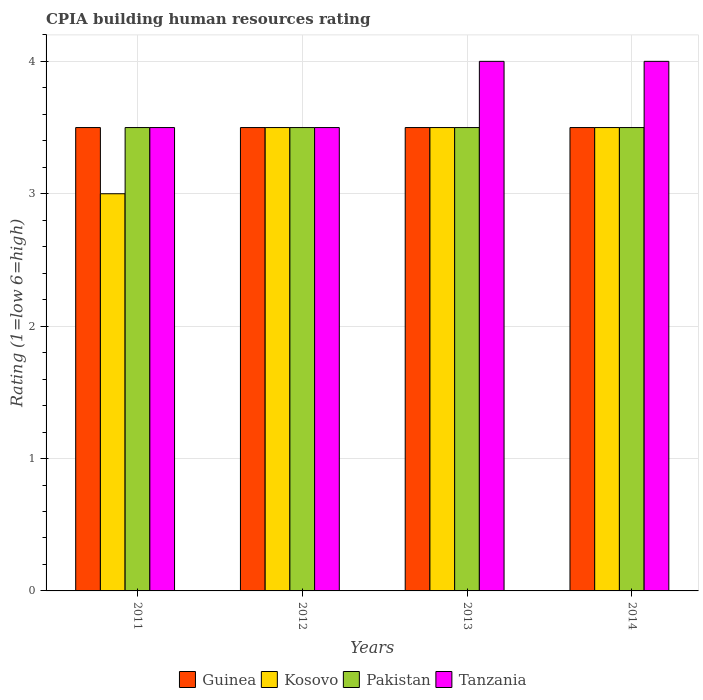Are the number of bars on each tick of the X-axis equal?
Offer a terse response. Yes. How many bars are there on the 4th tick from the left?
Offer a very short reply. 4. How many bars are there on the 2nd tick from the right?
Provide a short and direct response. 4. What is the label of the 1st group of bars from the left?
Provide a succinct answer. 2011. What is the CPIA rating in Guinea in 2014?
Provide a short and direct response. 3.5. In which year was the CPIA rating in Pakistan maximum?
Offer a very short reply. 2011. In which year was the CPIA rating in Guinea minimum?
Give a very brief answer. 2011. What is the difference between the CPIA rating in Kosovo in 2011 and that in 2012?
Give a very brief answer. -0.5. What is the average CPIA rating in Kosovo per year?
Keep it short and to the point. 3.38. What is the difference between the highest and the lowest CPIA rating in Pakistan?
Provide a succinct answer. 0. What does the 1st bar from the left in 2011 represents?
Keep it short and to the point. Guinea. How many bars are there?
Keep it short and to the point. 16. Are all the bars in the graph horizontal?
Your answer should be very brief. No. How many years are there in the graph?
Make the answer very short. 4. What is the difference between two consecutive major ticks on the Y-axis?
Offer a very short reply. 1. Where does the legend appear in the graph?
Give a very brief answer. Bottom center. What is the title of the graph?
Your response must be concise. CPIA building human resources rating. What is the label or title of the X-axis?
Ensure brevity in your answer.  Years. What is the Rating (1=low 6=high) in Kosovo in 2011?
Give a very brief answer. 3. What is the Rating (1=low 6=high) in Pakistan in 2011?
Offer a terse response. 3.5. What is the Rating (1=low 6=high) in Kosovo in 2012?
Give a very brief answer. 3.5. What is the Rating (1=low 6=high) in Pakistan in 2012?
Your response must be concise. 3.5. What is the Rating (1=low 6=high) of Tanzania in 2012?
Keep it short and to the point. 3.5. What is the Rating (1=low 6=high) in Guinea in 2013?
Ensure brevity in your answer.  3.5. What is the Rating (1=low 6=high) in Pakistan in 2013?
Offer a very short reply. 3.5. What is the Rating (1=low 6=high) in Guinea in 2014?
Offer a terse response. 3.5. Across all years, what is the maximum Rating (1=low 6=high) in Guinea?
Keep it short and to the point. 3.5. Across all years, what is the maximum Rating (1=low 6=high) of Tanzania?
Ensure brevity in your answer.  4. Across all years, what is the minimum Rating (1=low 6=high) of Kosovo?
Ensure brevity in your answer.  3. What is the total Rating (1=low 6=high) of Kosovo in the graph?
Your answer should be very brief. 13.5. What is the total Rating (1=low 6=high) of Pakistan in the graph?
Keep it short and to the point. 14. What is the total Rating (1=low 6=high) of Tanzania in the graph?
Your answer should be compact. 15. What is the difference between the Rating (1=low 6=high) in Kosovo in 2011 and that in 2012?
Your answer should be very brief. -0.5. What is the difference between the Rating (1=low 6=high) of Pakistan in 2011 and that in 2012?
Your response must be concise. 0. What is the difference between the Rating (1=low 6=high) of Tanzania in 2011 and that in 2012?
Your answer should be compact. 0. What is the difference between the Rating (1=low 6=high) of Kosovo in 2011 and that in 2013?
Provide a short and direct response. -0.5. What is the difference between the Rating (1=low 6=high) of Guinea in 2011 and that in 2014?
Your answer should be very brief. 0. What is the difference between the Rating (1=low 6=high) in Tanzania in 2011 and that in 2014?
Ensure brevity in your answer.  -0.5. What is the difference between the Rating (1=low 6=high) of Kosovo in 2012 and that in 2013?
Give a very brief answer. 0. What is the difference between the Rating (1=low 6=high) of Tanzania in 2012 and that in 2013?
Your response must be concise. -0.5. What is the difference between the Rating (1=low 6=high) of Guinea in 2012 and that in 2014?
Keep it short and to the point. 0. What is the difference between the Rating (1=low 6=high) of Kosovo in 2012 and that in 2014?
Your answer should be compact. 0. What is the difference between the Rating (1=low 6=high) of Kosovo in 2013 and that in 2014?
Ensure brevity in your answer.  0. What is the difference between the Rating (1=low 6=high) of Pakistan in 2013 and that in 2014?
Offer a terse response. 0. What is the difference between the Rating (1=low 6=high) in Guinea in 2011 and the Rating (1=low 6=high) in Kosovo in 2012?
Your response must be concise. 0. What is the difference between the Rating (1=low 6=high) in Guinea in 2011 and the Rating (1=low 6=high) in Pakistan in 2012?
Ensure brevity in your answer.  0. What is the difference between the Rating (1=low 6=high) of Guinea in 2011 and the Rating (1=low 6=high) of Tanzania in 2012?
Your response must be concise. 0. What is the difference between the Rating (1=low 6=high) of Kosovo in 2011 and the Rating (1=low 6=high) of Pakistan in 2012?
Your response must be concise. -0.5. What is the difference between the Rating (1=low 6=high) of Pakistan in 2011 and the Rating (1=low 6=high) of Tanzania in 2012?
Your answer should be very brief. 0. What is the difference between the Rating (1=low 6=high) in Guinea in 2011 and the Rating (1=low 6=high) in Kosovo in 2013?
Provide a short and direct response. 0. What is the difference between the Rating (1=low 6=high) of Guinea in 2011 and the Rating (1=low 6=high) of Pakistan in 2013?
Give a very brief answer. 0. What is the difference between the Rating (1=low 6=high) in Guinea in 2011 and the Rating (1=low 6=high) in Tanzania in 2013?
Provide a succinct answer. -0.5. What is the difference between the Rating (1=low 6=high) in Kosovo in 2011 and the Rating (1=low 6=high) in Pakistan in 2013?
Your answer should be very brief. -0.5. What is the difference between the Rating (1=low 6=high) of Guinea in 2011 and the Rating (1=low 6=high) of Kosovo in 2014?
Offer a very short reply. 0. What is the difference between the Rating (1=low 6=high) in Guinea in 2011 and the Rating (1=low 6=high) in Pakistan in 2014?
Provide a short and direct response. 0. What is the difference between the Rating (1=low 6=high) of Kosovo in 2011 and the Rating (1=low 6=high) of Pakistan in 2014?
Keep it short and to the point. -0.5. What is the difference between the Rating (1=low 6=high) of Guinea in 2012 and the Rating (1=low 6=high) of Kosovo in 2013?
Give a very brief answer. 0. What is the difference between the Rating (1=low 6=high) in Kosovo in 2012 and the Rating (1=low 6=high) in Tanzania in 2013?
Offer a very short reply. -0.5. What is the difference between the Rating (1=low 6=high) in Pakistan in 2012 and the Rating (1=low 6=high) in Tanzania in 2013?
Your answer should be very brief. -0.5. What is the difference between the Rating (1=low 6=high) in Guinea in 2012 and the Rating (1=low 6=high) in Kosovo in 2014?
Offer a terse response. 0. What is the difference between the Rating (1=low 6=high) of Guinea in 2012 and the Rating (1=low 6=high) of Pakistan in 2014?
Give a very brief answer. 0. What is the difference between the Rating (1=low 6=high) of Guinea in 2013 and the Rating (1=low 6=high) of Tanzania in 2014?
Make the answer very short. -0.5. What is the difference between the Rating (1=low 6=high) in Kosovo in 2013 and the Rating (1=low 6=high) in Pakistan in 2014?
Your answer should be very brief. 0. What is the difference between the Rating (1=low 6=high) of Pakistan in 2013 and the Rating (1=low 6=high) of Tanzania in 2014?
Make the answer very short. -0.5. What is the average Rating (1=low 6=high) of Guinea per year?
Keep it short and to the point. 3.5. What is the average Rating (1=low 6=high) of Kosovo per year?
Your answer should be very brief. 3.38. What is the average Rating (1=low 6=high) in Tanzania per year?
Offer a very short reply. 3.75. In the year 2011, what is the difference between the Rating (1=low 6=high) in Guinea and Rating (1=low 6=high) in Kosovo?
Ensure brevity in your answer.  0.5. In the year 2012, what is the difference between the Rating (1=low 6=high) in Guinea and Rating (1=low 6=high) in Kosovo?
Ensure brevity in your answer.  0. In the year 2012, what is the difference between the Rating (1=low 6=high) of Guinea and Rating (1=low 6=high) of Pakistan?
Provide a short and direct response. 0. In the year 2012, what is the difference between the Rating (1=low 6=high) in Guinea and Rating (1=low 6=high) in Tanzania?
Offer a terse response. 0. In the year 2012, what is the difference between the Rating (1=low 6=high) in Kosovo and Rating (1=low 6=high) in Tanzania?
Offer a terse response. 0. In the year 2013, what is the difference between the Rating (1=low 6=high) in Guinea and Rating (1=low 6=high) in Tanzania?
Keep it short and to the point. -0.5. In the year 2013, what is the difference between the Rating (1=low 6=high) of Kosovo and Rating (1=low 6=high) of Tanzania?
Your answer should be compact. -0.5. In the year 2014, what is the difference between the Rating (1=low 6=high) of Guinea and Rating (1=low 6=high) of Kosovo?
Your response must be concise. 0. In the year 2014, what is the difference between the Rating (1=low 6=high) in Kosovo and Rating (1=low 6=high) in Pakistan?
Provide a short and direct response. 0. In the year 2014, what is the difference between the Rating (1=low 6=high) in Kosovo and Rating (1=low 6=high) in Tanzania?
Offer a terse response. -0.5. In the year 2014, what is the difference between the Rating (1=low 6=high) of Pakistan and Rating (1=low 6=high) of Tanzania?
Provide a succinct answer. -0.5. What is the ratio of the Rating (1=low 6=high) of Guinea in 2011 to that in 2012?
Offer a terse response. 1. What is the ratio of the Rating (1=low 6=high) of Tanzania in 2011 to that in 2012?
Make the answer very short. 1. What is the ratio of the Rating (1=low 6=high) of Guinea in 2011 to that in 2013?
Offer a very short reply. 1. What is the ratio of the Rating (1=low 6=high) in Tanzania in 2011 to that in 2013?
Make the answer very short. 0.88. What is the ratio of the Rating (1=low 6=high) in Pakistan in 2011 to that in 2014?
Keep it short and to the point. 1. What is the ratio of the Rating (1=low 6=high) of Guinea in 2012 to that in 2014?
Keep it short and to the point. 1. What is the ratio of the Rating (1=low 6=high) of Kosovo in 2012 to that in 2014?
Offer a very short reply. 1. What is the ratio of the Rating (1=low 6=high) of Pakistan in 2012 to that in 2014?
Give a very brief answer. 1. What is the ratio of the Rating (1=low 6=high) of Pakistan in 2013 to that in 2014?
Your answer should be compact. 1. What is the ratio of the Rating (1=low 6=high) of Tanzania in 2013 to that in 2014?
Provide a succinct answer. 1. What is the difference between the highest and the second highest Rating (1=low 6=high) of Guinea?
Offer a very short reply. 0. What is the difference between the highest and the second highest Rating (1=low 6=high) of Kosovo?
Offer a very short reply. 0. What is the difference between the highest and the second highest Rating (1=low 6=high) of Pakistan?
Your answer should be very brief. 0. What is the difference between the highest and the lowest Rating (1=low 6=high) in Kosovo?
Ensure brevity in your answer.  0.5. 